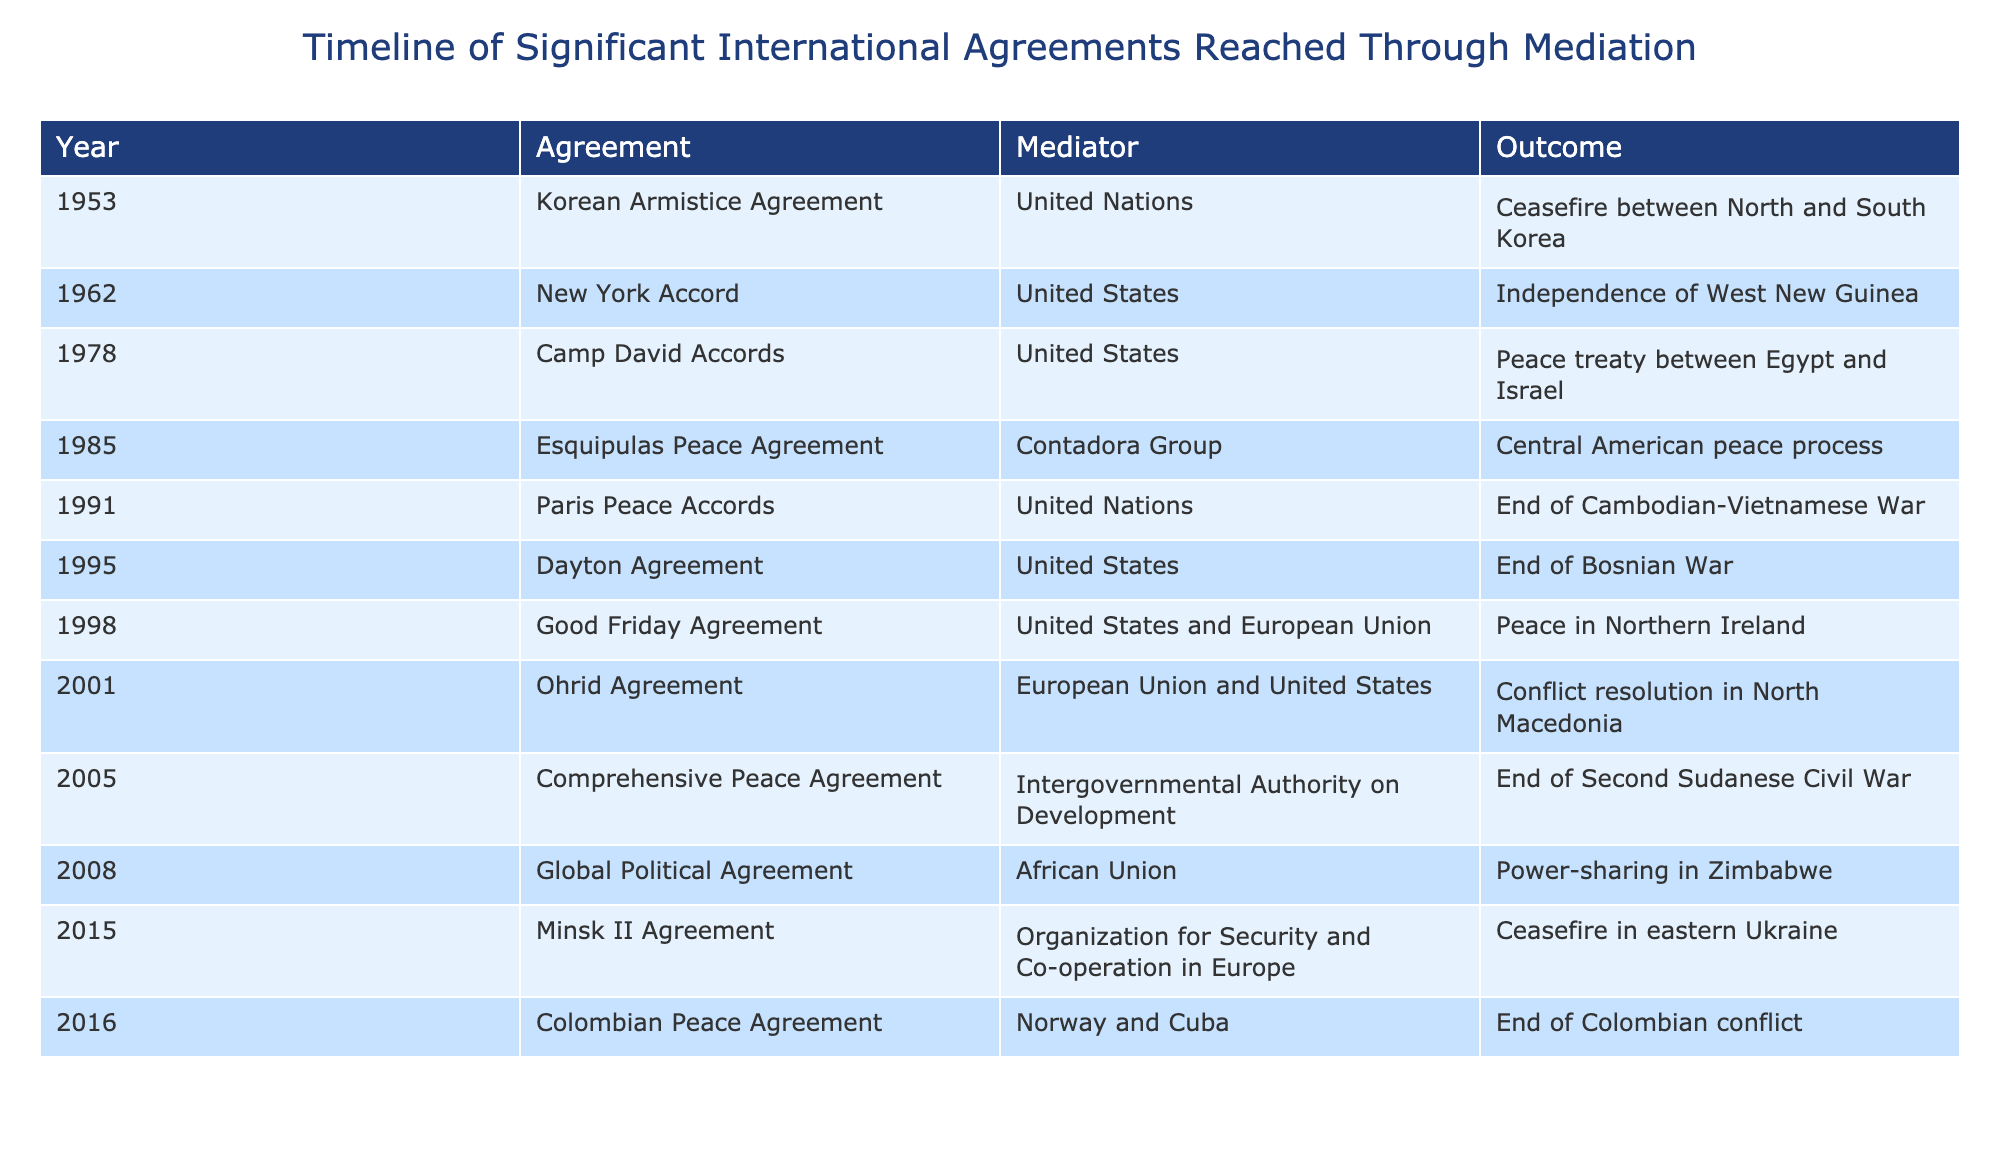What year was the Good Friday Agreement signed? By reviewing the table, the year associated with the Good Friday Agreement is identified in the "Year" column corresponding to the entry for this agreement.
Answer: 1998 Who mediated the Camp David Accords? The mediator for the Camp David Accords is listed in the "Mediator" column for the corresponding entry in the table.
Answer: United States Which agreement led to a ceasefire in eastern Ukraine? The table lists the "Outcome" for each agreement; the one indicating a ceasefire in eastern Ukraine is found by locating the corresponding entry in the "Agreement" column.
Answer: Minsk II Agreement How many agreements were mediated by the United States? To find the total, count the number of entries in the "Mediator" column that involve the United States. After counting, there are four such entries.
Answer: 4 What is the outcome of the Comprehensive Peace Agreement? Referring to the "Outcome" column of the table will provide the specific outcome listed next to the Comprehensive Peace Agreement entry.
Answer: End of Second Sudanese Civil War Was the Paris Peace Accords mediated by the United Nations? By checking the "Mediator" column for the Paris Peace Accords entry, we can confirm that it was indeed mediated by the United Nations.
Answer: Yes Which agreement marked the end of the Colombian conflict? The "Outcome" column provides insights into the conflicts resolved; checking for the outcome describing the end of the Colombian conflict leads to identifying the respective agreement.
Answer: Colombian Peace Agreement What is the number of agreements associated with the United Nations as mediators? Count the entries in the "Mediator" column for all agreements where the Mediator is listed as the United Nations; there are three such agreements.
Answer: 3 In what year did the Dayton Agreement achieve its outcome? By locating the Dayton Agreement in the "Agreement" column, the year in the same row's "Year" column shows when it occurred.
Answer: 1995 Which agreement had the most recent outcome listed in the table? To find this, compare the years in the "Year" column; the most recent entry indicates the latest agreement reached through mediation, which is identified clearly as you look through the years.
Answer: Colombian Peace Agreement 